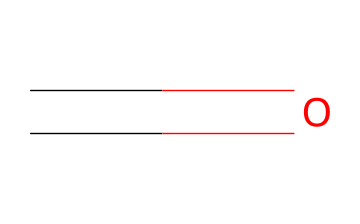What is the molecular formula of formaldehyde? The SMILES representation "C=O" indicates that there is one carbon atom and one oxygen atom present, which makes the molecular formula CH2O.
Answer: CH2O How many hydrogen atoms are in formaldehyde? From the molecular formula CH2O derived from the SMILES "C=O," there are two hydrogen atoms attached to the carbon atom.
Answer: 2 What type of functional group is present in formaldehyde? The "C=O" in the SMILES structure indicates a carbonyl group, which is characteristic of aldehydes.
Answer: aldehyde What is the total number of bonds in formaldehyde? There is one double bond between carbon and oxygen (C=O) and two single bonds between carbon and two hydrogen atoms (C-H); thus, the total number is three bonds.
Answer: 3 Does formaldehyde have any isomers? Analyzing the structure and functional group reveals that aldehydes have limited structural variability; formaldehyde has no structural isomers.
Answer: no 